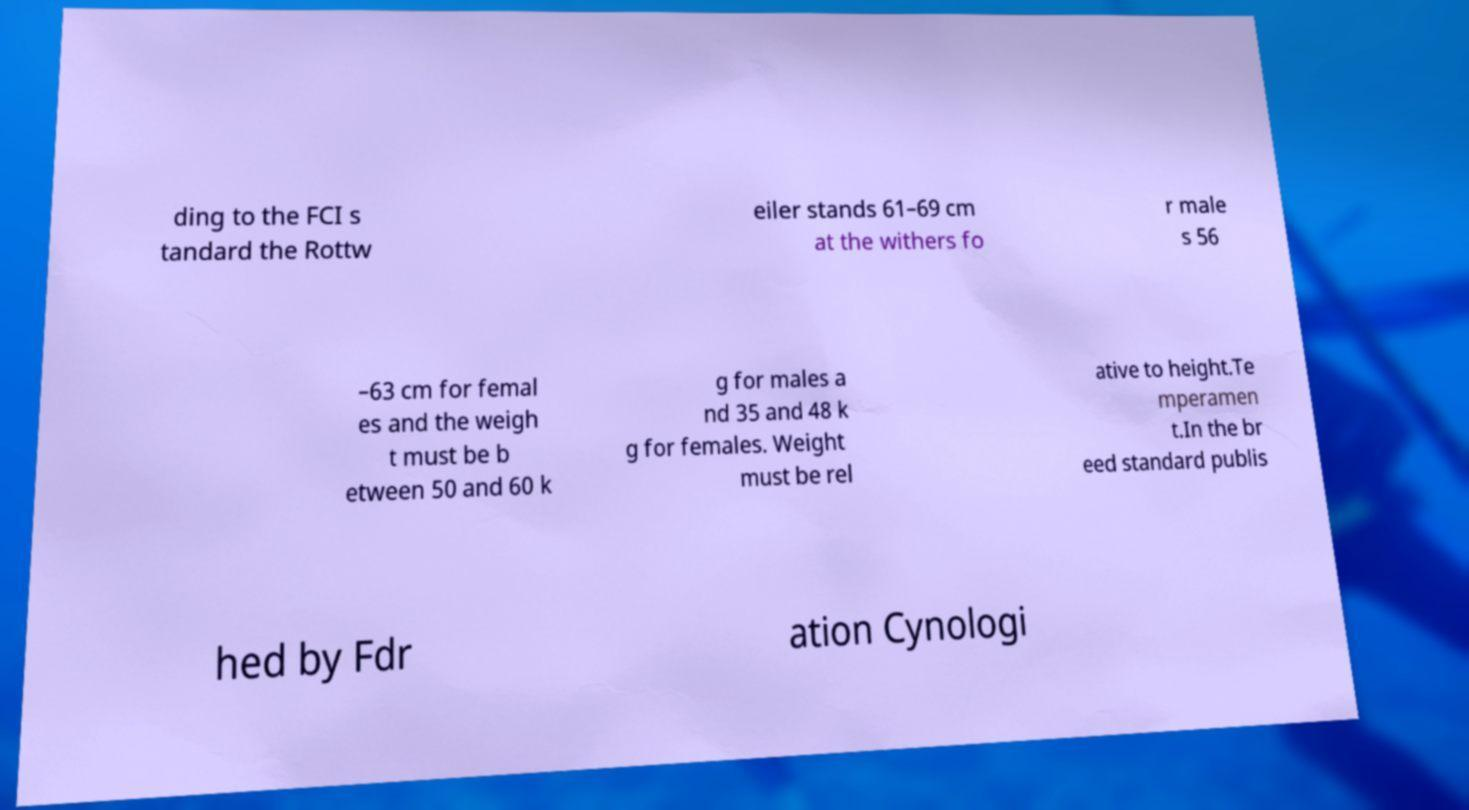What messages or text are displayed in this image? I need them in a readable, typed format. ding to the FCI s tandard the Rottw eiler stands 61–69 cm at the withers fo r male s 56 –63 cm for femal es and the weigh t must be b etween 50 and 60 k g for males a nd 35 and 48 k g for females. Weight must be rel ative to height.Te mperamen t.In the br eed standard publis hed by Fdr ation Cynologi 